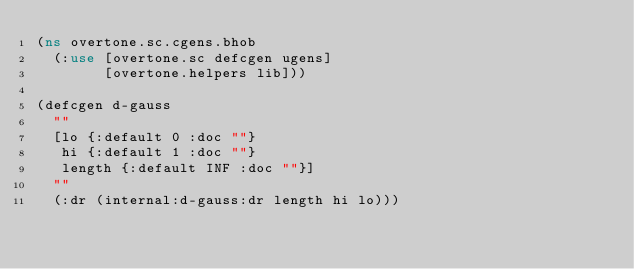Convert code to text. <code><loc_0><loc_0><loc_500><loc_500><_Clojure_>(ns overtone.sc.cgens.bhob
  (:use [overtone.sc defcgen ugens]
        [overtone.helpers lib]))

(defcgen d-gauss
  ""
  [lo {:default 0 :doc ""}
   hi {:default 1 :doc ""}
   length {:default INF :doc ""}]
  ""
  (:dr (internal:d-gauss:dr length hi lo)))
</code> 